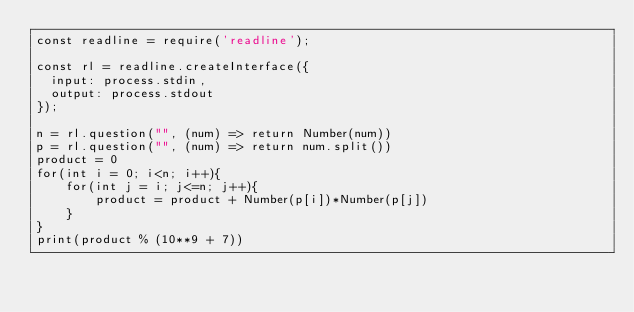Convert code to text. <code><loc_0><loc_0><loc_500><loc_500><_JavaScript_>const readline = require('readline');

const rl = readline.createInterface({
  input: process.stdin,
  output: process.stdout
});

n = rl.question("", (num) => return Number(num))
p = rl.question("", (num) => return num.split())
product = 0
for(int i = 0; i<n; i++){ 
    for(int j = i; j<=n; j++){ 
        product = product + Number(p[i])*Number(p[j]) 
    }
}
print(product % (10**9 + 7))</code> 